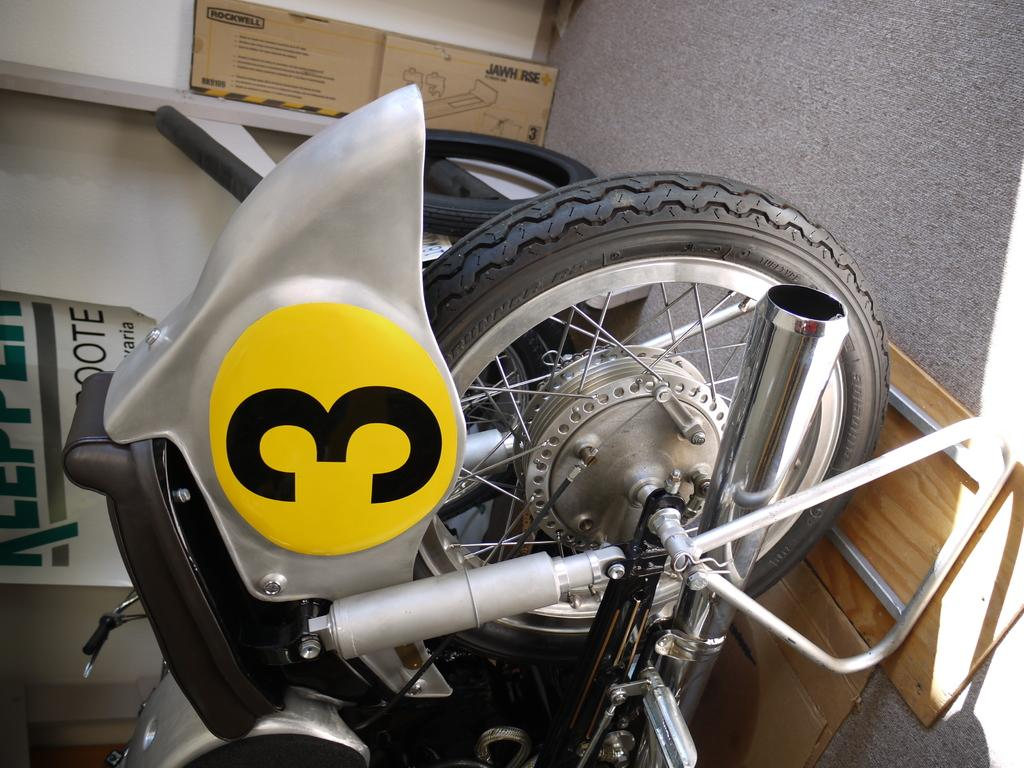Provide a one-sentence caption for the provided image. Type of motorcycle with the number three sticker on the back. 